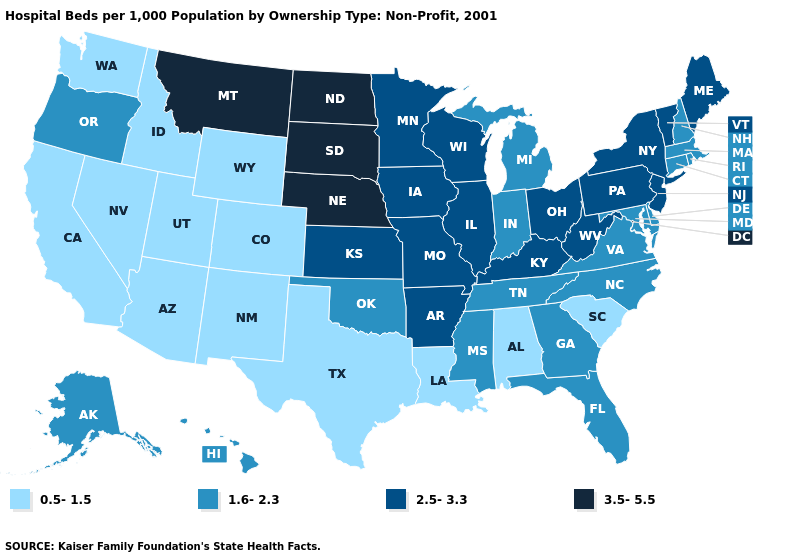Is the legend a continuous bar?
Concise answer only. No. Name the states that have a value in the range 2.5-3.3?
Concise answer only. Arkansas, Illinois, Iowa, Kansas, Kentucky, Maine, Minnesota, Missouri, New Jersey, New York, Ohio, Pennsylvania, Vermont, West Virginia, Wisconsin. What is the value of Oregon?
Short answer required. 1.6-2.3. Among the states that border Delaware , which have the highest value?
Be succinct. New Jersey, Pennsylvania. What is the value of Oklahoma?
Be succinct. 1.6-2.3. Name the states that have a value in the range 1.6-2.3?
Answer briefly. Alaska, Connecticut, Delaware, Florida, Georgia, Hawaii, Indiana, Maryland, Massachusetts, Michigan, Mississippi, New Hampshire, North Carolina, Oklahoma, Oregon, Rhode Island, Tennessee, Virginia. Name the states that have a value in the range 2.5-3.3?
Be succinct. Arkansas, Illinois, Iowa, Kansas, Kentucky, Maine, Minnesota, Missouri, New Jersey, New York, Ohio, Pennsylvania, Vermont, West Virginia, Wisconsin. What is the highest value in the USA?
Short answer required. 3.5-5.5. Name the states that have a value in the range 2.5-3.3?
Quick response, please. Arkansas, Illinois, Iowa, Kansas, Kentucky, Maine, Minnesota, Missouri, New Jersey, New York, Ohio, Pennsylvania, Vermont, West Virginia, Wisconsin. What is the value of South Dakota?
Short answer required. 3.5-5.5. Name the states that have a value in the range 2.5-3.3?
Concise answer only. Arkansas, Illinois, Iowa, Kansas, Kentucky, Maine, Minnesota, Missouri, New Jersey, New York, Ohio, Pennsylvania, Vermont, West Virginia, Wisconsin. Is the legend a continuous bar?
Concise answer only. No. Name the states that have a value in the range 3.5-5.5?
Concise answer only. Montana, Nebraska, North Dakota, South Dakota. Name the states that have a value in the range 2.5-3.3?
Give a very brief answer. Arkansas, Illinois, Iowa, Kansas, Kentucky, Maine, Minnesota, Missouri, New Jersey, New York, Ohio, Pennsylvania, Vermont, West Virginia, Wisconsin. Does the map have missing data?
Quick response, please. No. 